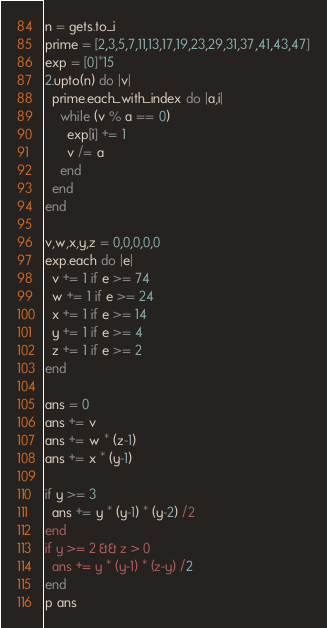Convert code to text. <code><loc_0><loc_0><loc_500><loc_500><_Ruby_>n = gets.to_i
prime = [2,3,5,7,11,13,17,19,23,29,31,37,41,43,47]
exp = [0]*15
2.upto(n) do |v|
  prime.each_with_index do |a,i|
    while (v % a == 0)
      exp[i] += 1
      v /= a
    end
  end
end

v,w,x,y,z = 0,0,0,0,0
exp.each do |e|
  v += 1 if e >= 74
  w += 1 if e >= 24
  x += 1 if e >= 14
  y += 1 if e >= 4
  z += 1 if e >= 2
end

ans = 0
ans += v
ans += w * (z-1)
ans += x * (y-1)

if y >= 3
  ans += y * (y-1) * (y-2) /2
end
if y >= 2 && z > 0
  ans += y * (y-1) * (z-y) /2
end
p ans</code> 